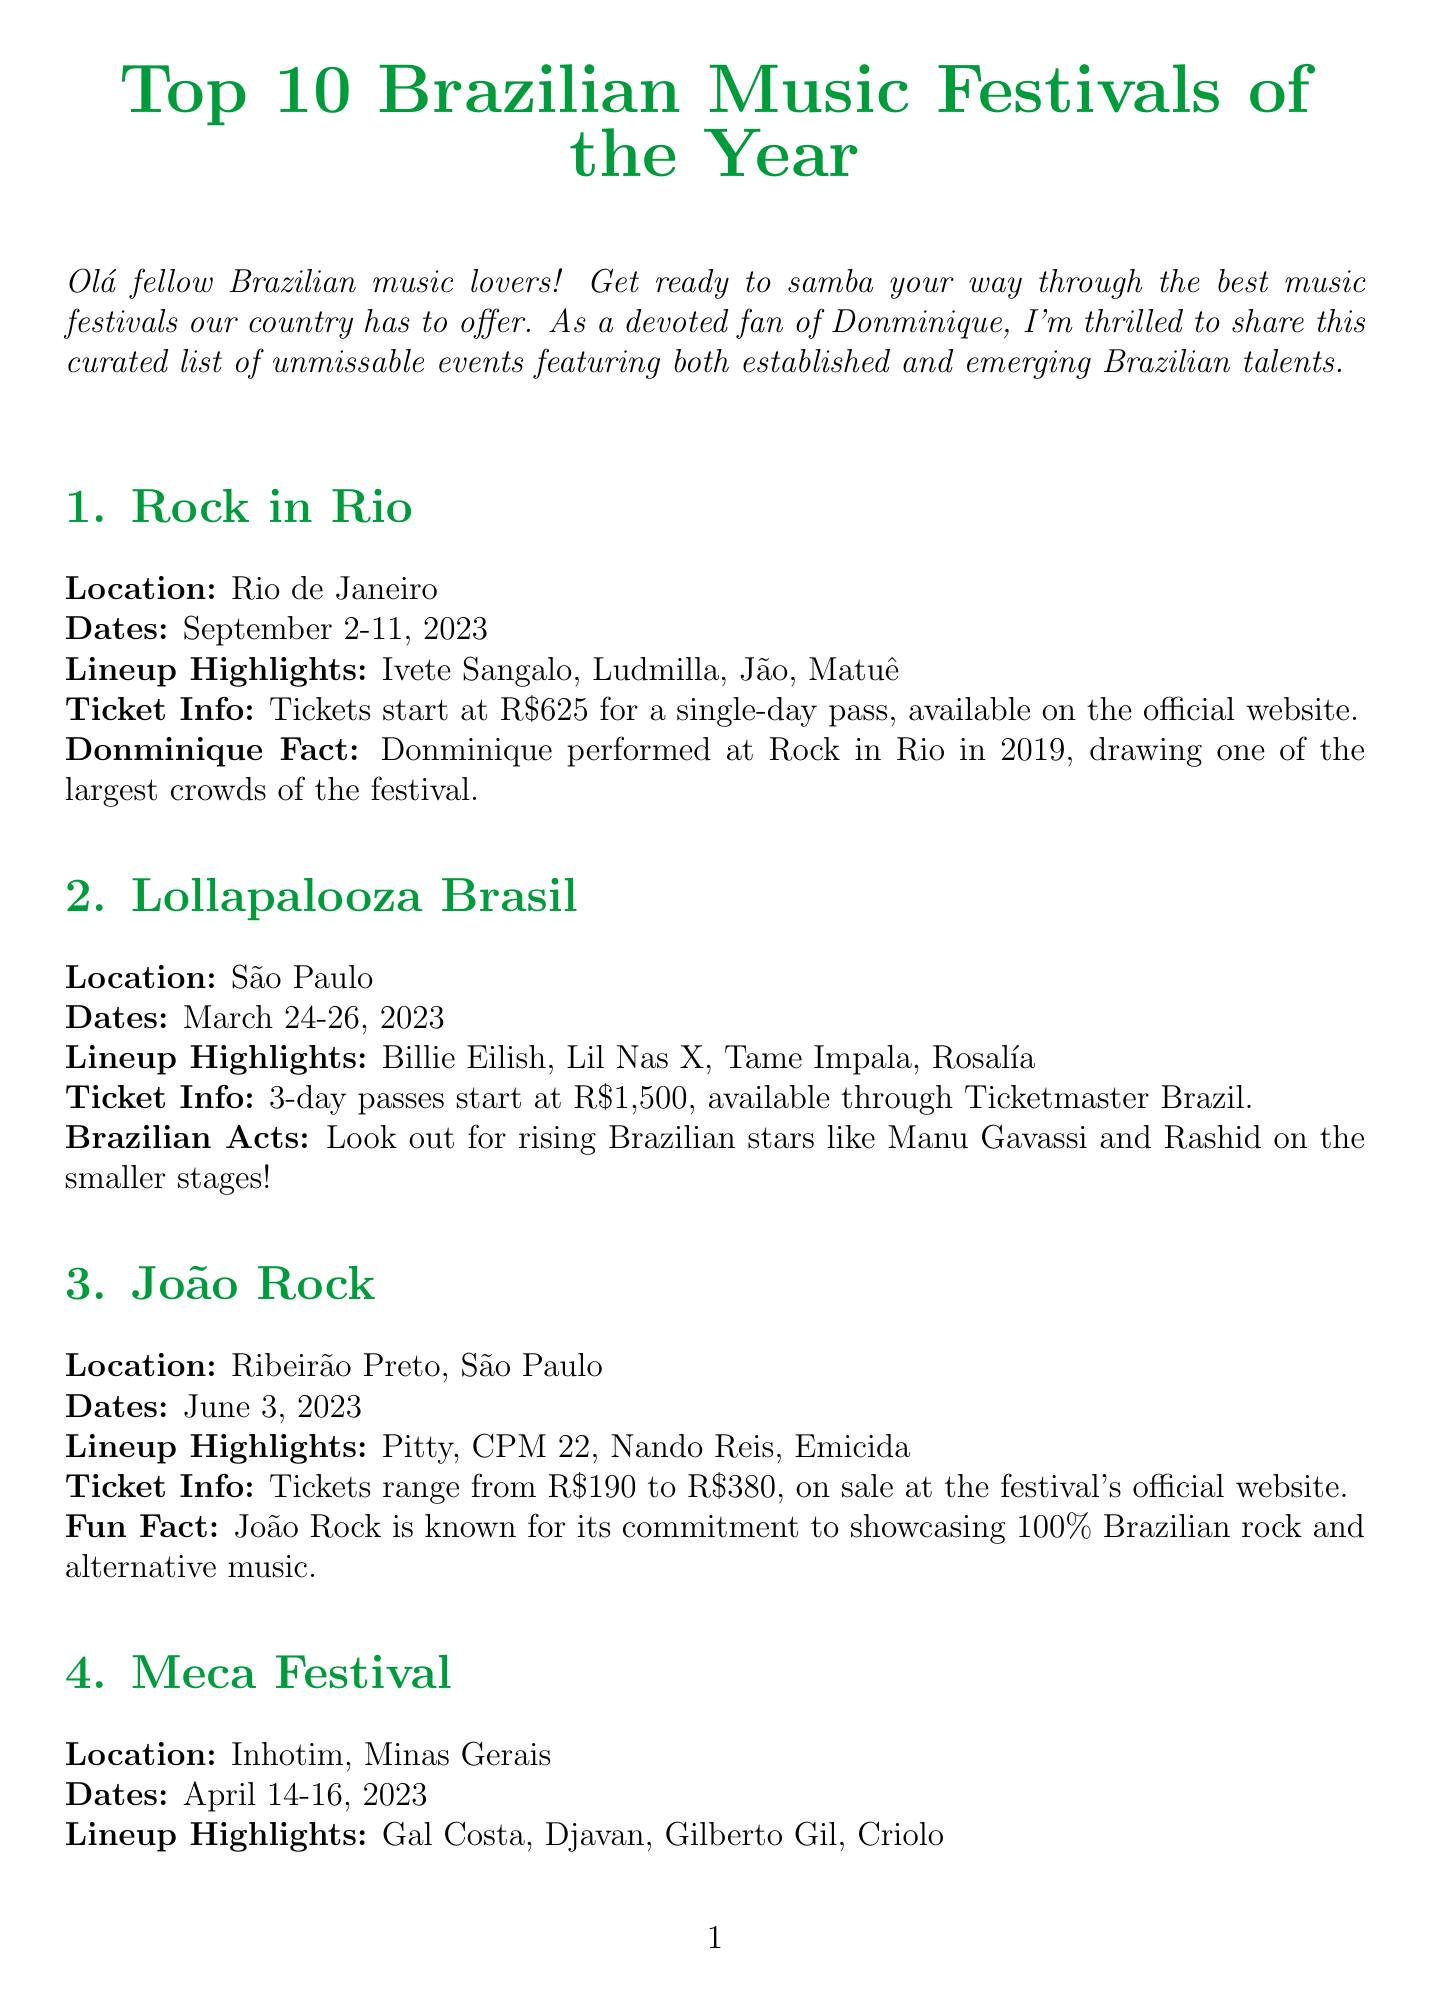what is the location of Rock in Rio? The document states that Rock in Rio takes place in Rio de Janeiro.
Answer: Rio de Janeiro what are the dates for Lollapalooza Brasil? The document provides the dates for Lollapalooza Brasil as March 24-26, 2023.
Answer: March 24-26, 2023 who performed at João Rock? According to the document, artists like Pitty, CPM 22, Nando Reis, and Emicida are highlighted in the lineup.
Answer: Pitty, CPM 22, Nando Reis, Emicida how much do tickets start for Planeta Brasil? The document mentions that 2-day passes for Planeta Brasil start at R$300.
Answer: R$300 what is unique about Meca Festival? The document notes that Meca Festival is set in the Inhotim open-air art museum and offers a blend of music and visual arts.
Answer: Blend of music and visual arts how does Coala Festival promote sustainability? The document states that Coala Festival is known for its sustainability initiatives, including a zero-waste policy.
Answer: Zero-waste policy which festival features free admission? The document highlights that Festival Rec-Beat has free admission as part of Recife's Carnival celebrations.
Answer: Festival Rec-Beat when does Universo Spanta take place? The specified dates for Universo Spanta in the document are January 4-29, 2023.
Answer: January 4-29, 2023 what is the ticket price range for João Rock? The document indicates that tickets for João Rock range from R$190 to R$380.
Answer: R$190 to R$380 